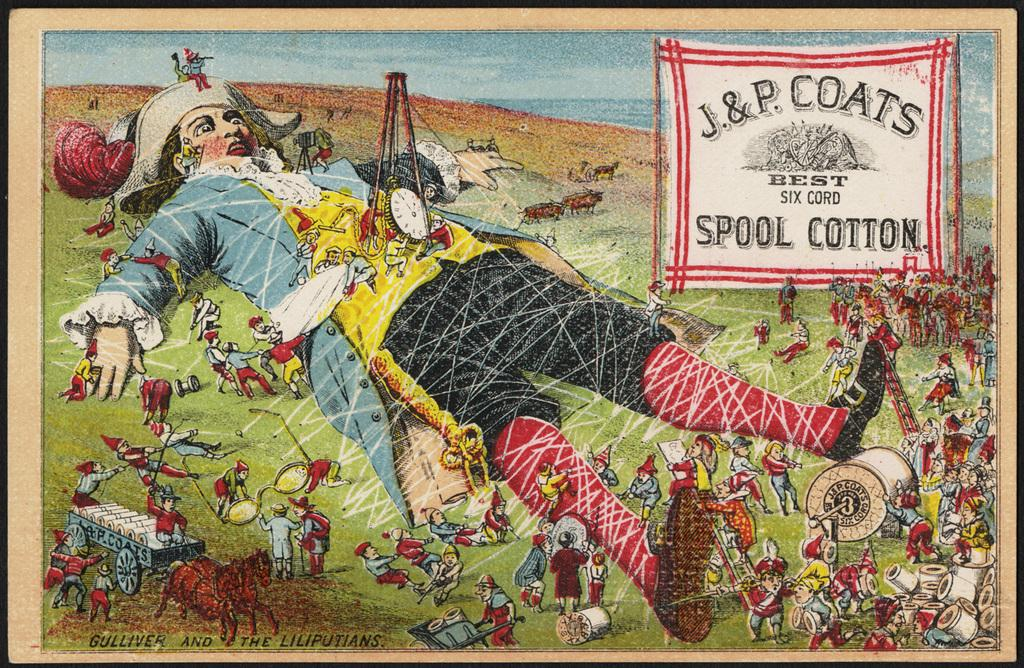<image>
Provide a brief description of the given image. An image with box that says J & R Coats Spool Cotton. 